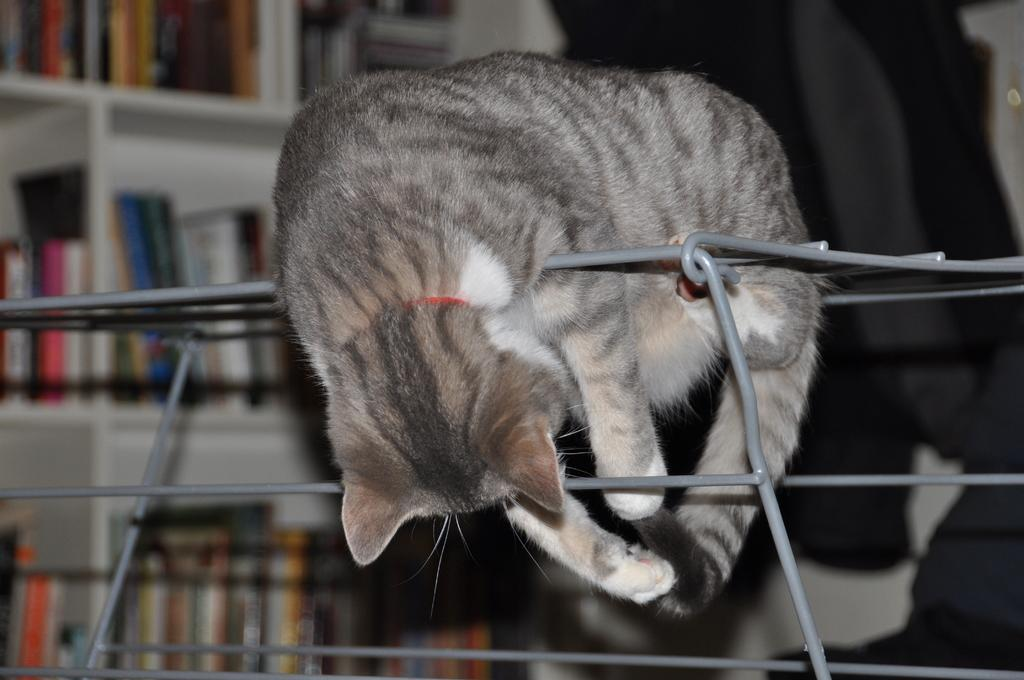What type of animal is in the image? There is a cat in the image. What is the cat standing on? The cat is on metal rods. What can be seen in the background of the image? There are books in the background of the image. How are the books arranged in the image? The books are in racks. What type of doctor is attending to the cat in the image? There is no doctor present in the image; it only features a cat on metal rods and books in racks. 